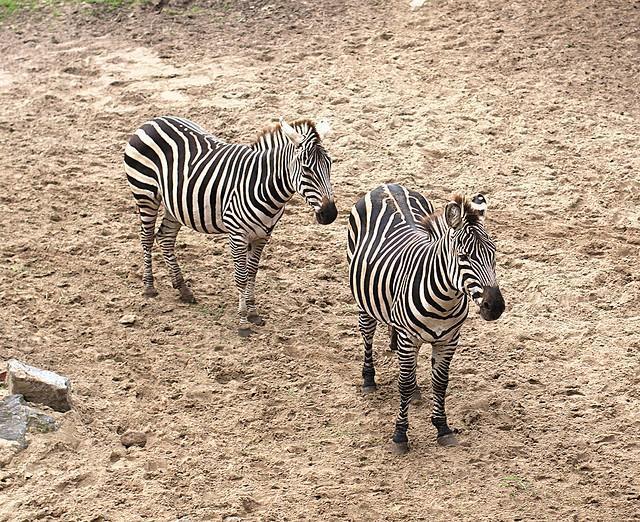How many zebras are there?
Give a very brief answer. 2. How many zebras are visible?
Give a very brief answer. 2. 